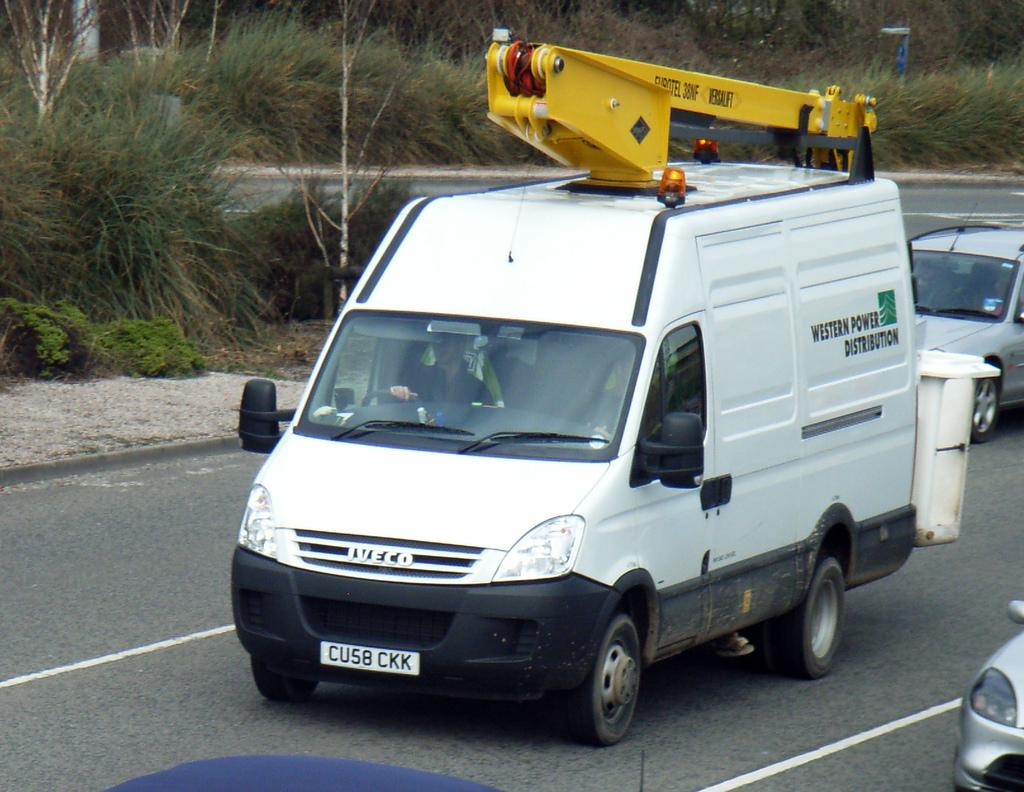<image>
Render a clear and concise summary of the photo. A white van with a crane on top says Western Power Distribution. 